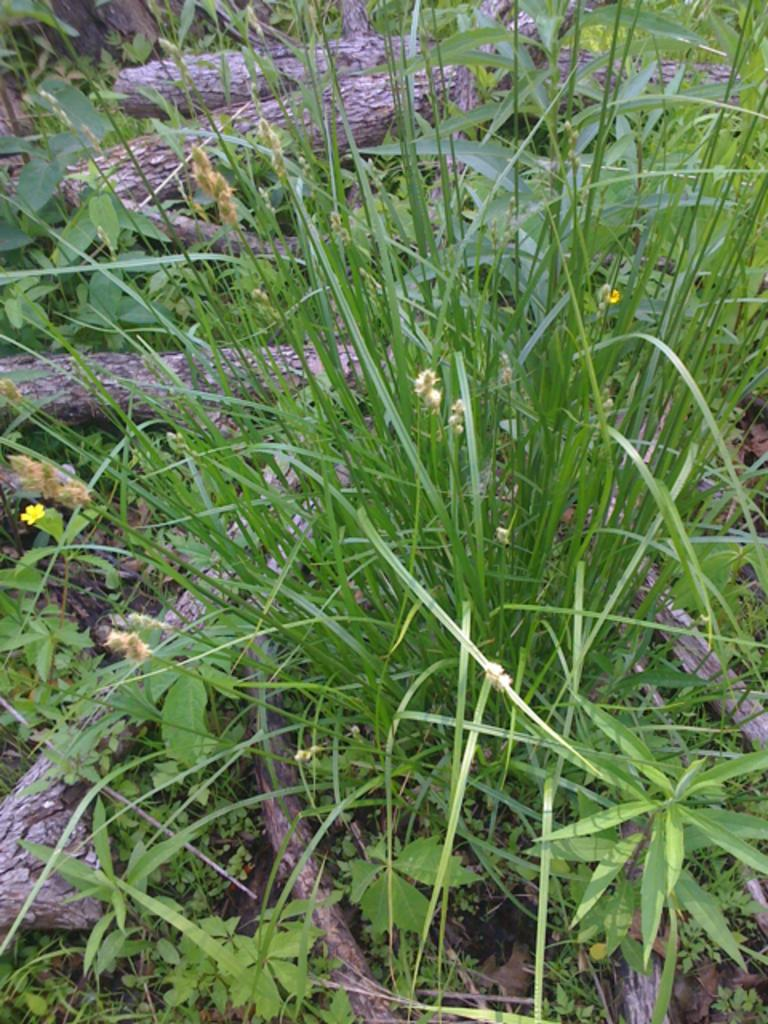What type of material is used to make the logs in the image? The logs in the image are made of wood. What is the surface on which the logs are placed? There is grass on the surface in the image. What type of apparatus is used to start a fire with the wooden logs in the image? There is no apparatus or fire present in the image; it only shows wooden logs and grass. 